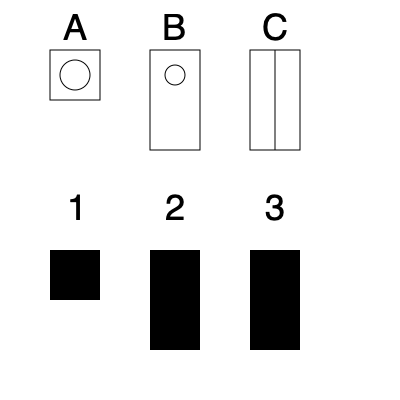Match the ophthalmological instruments (A, B, C) with their corresponding shadows (1, 2, 3) after mentally rotating them 90 degrees clockwise. Which instrument corresponds to shadow 2? To solve this problem, we need to mentally rotate each instrument 90 degrees clockwise and compare it to the given shadows:

1. Instrument A (Tonometer):
   - After rotation, it would appear as a square with a circle on the side.
   - This matches shadow 1.

2. Instrument B (Ophthalmoscope):
   - After rotation, it would appear as a tall, narrow rectangle.
   - This matches shadow 2.

3. Instrument C (Slit Lamp):
   - After rotation, it would appear as a tall rectangle with a line through the middle.
   - This matches shadow 3.

Therefore, instrument B (Ophthalmoscope) corresponds to shadow 2.
Answer: B 